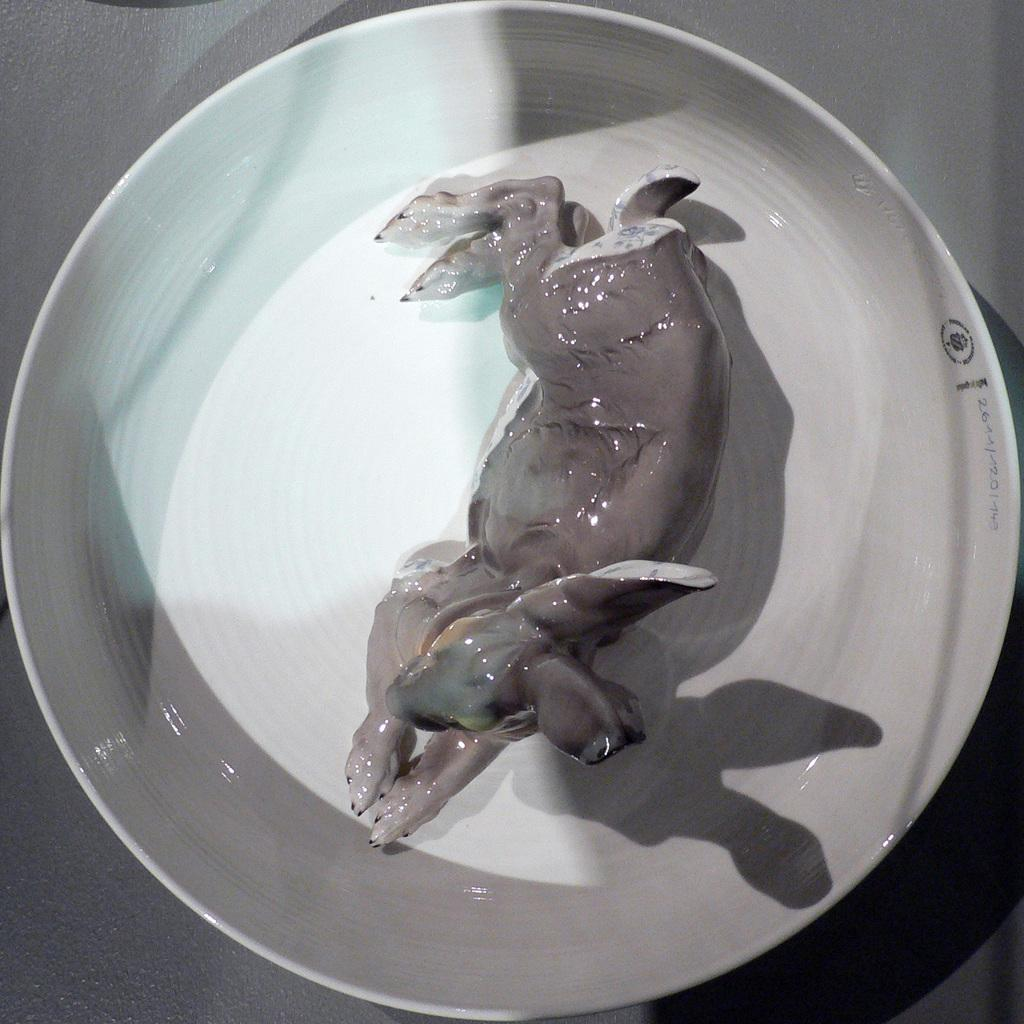What type of animal can be seen in the image? There is an animal in the image, but its specific type cannot be determined from the provided facts. How is the animal contained in the image? The animal is kept in a bowl. What color is the bowl that contains the animal? The bowl is white in color. Where is the bowl placed in the image? The bowl is placed on a table. Is the animal covered in dirt in the image? There is no information about the animal's condition or appearance in the image, so it cannot be determined if it is covered in dirt. 